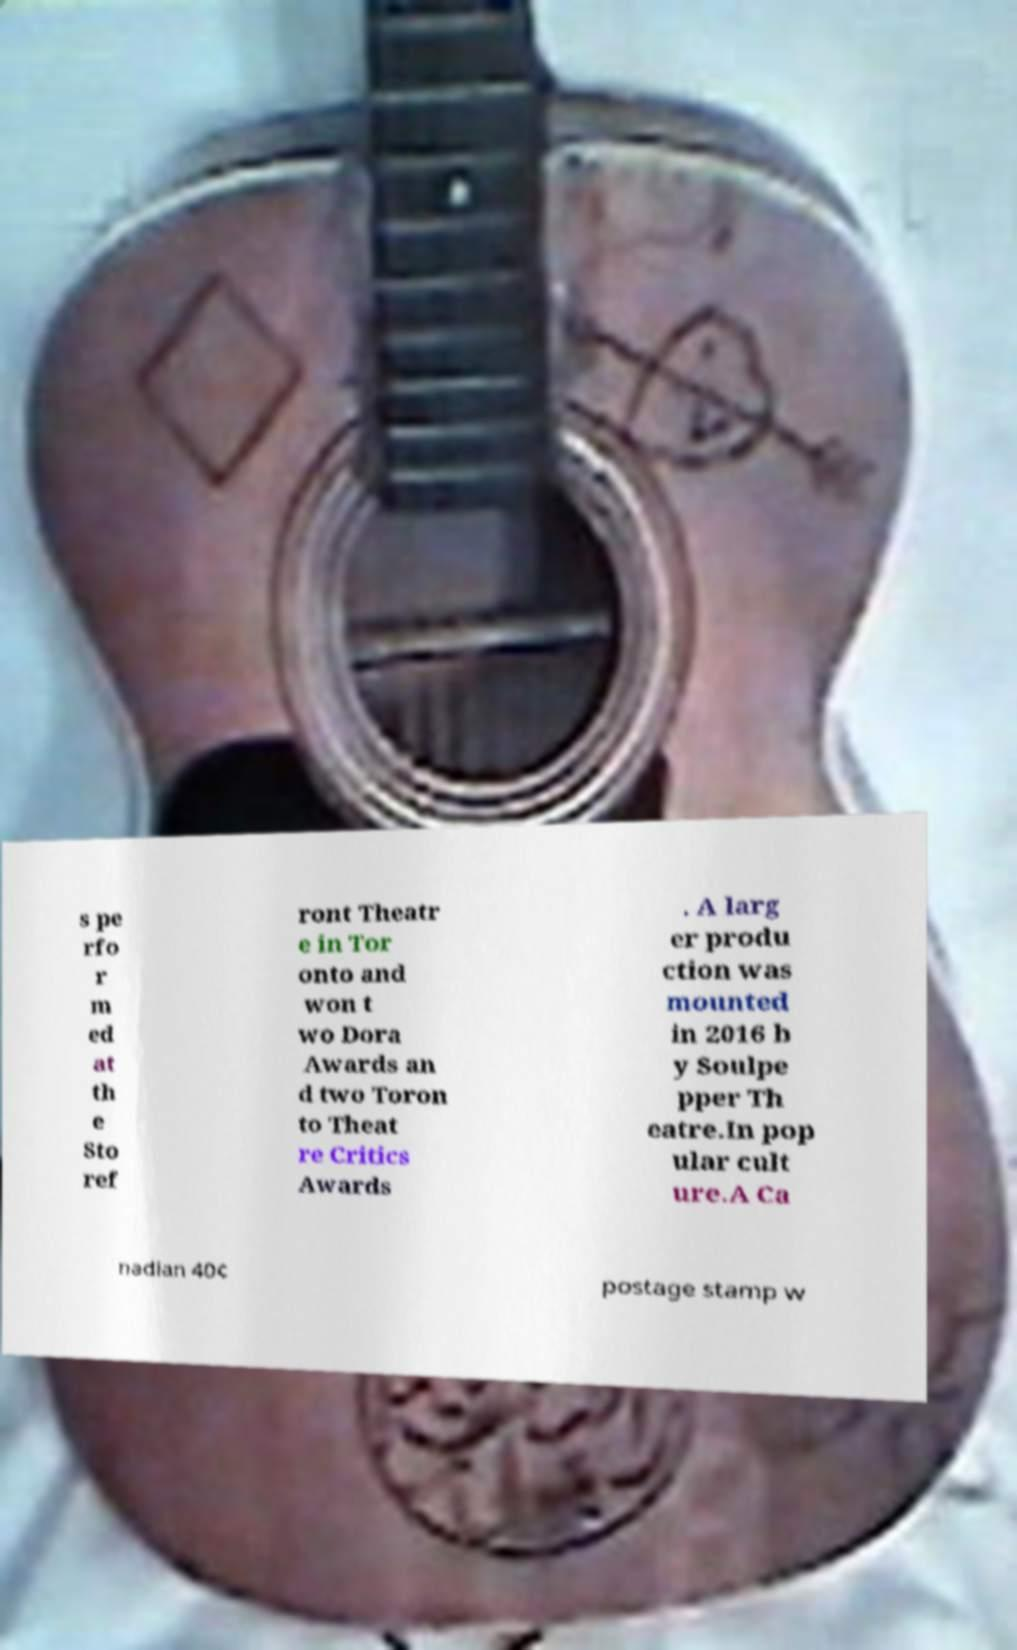For documentation purposes, I need the text within this image transcribed. Could you provide that? s pe rfo r m ed at th e Sto ref ront Theatr e in Tor onto and won t wo Dora Awards an d two Toron to Theat re Critics Awards . A larg er produ ction was mounted in 2016 b y Soulpe pper Th eatre.In pop ular cult ure.A Ca nadian 40¢ postage stamp w 